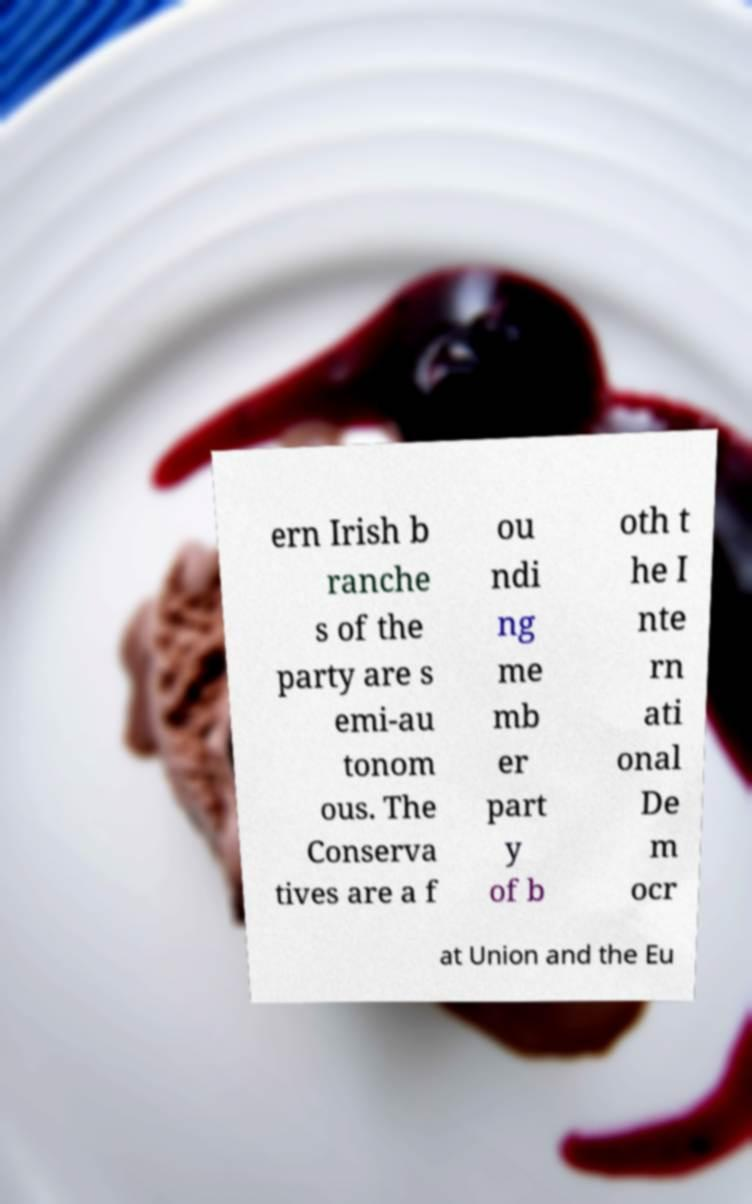Can you accurately transcribe the text from the provided image for me? ern Irish b ranche s of the party are s emi-au tonom ous. The Conserva tives are a f ou ndi ng me mb er part y of b oth t he I nte rn ati onal De m ocr at Union and the Eu 